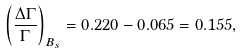<formula> <loc_0><loc_0><loc_500><loc_500>\left ( \frac { \Delta \Gamma } { \Gamma } \right ) _ { B _ { s } } = 0 . 2 2 0 - 0 . 0 6 5 = 0 . 1 5 5 ,</formula> 